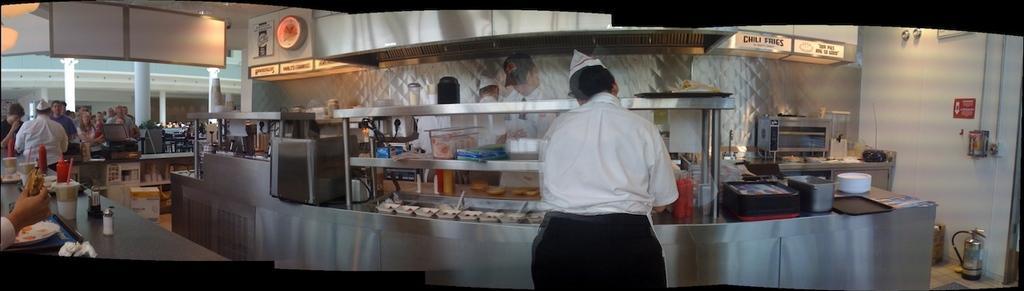Please provide a concise description of this image. In this image, we can see few people, kitchen platform, machines, buckets and objects. On the right side, we can see wall, pipes, poster, fire extinguisher. Left side of the image, we can see a group of people. Here we can see desk, few things and items. Background we can see pillars and walls 